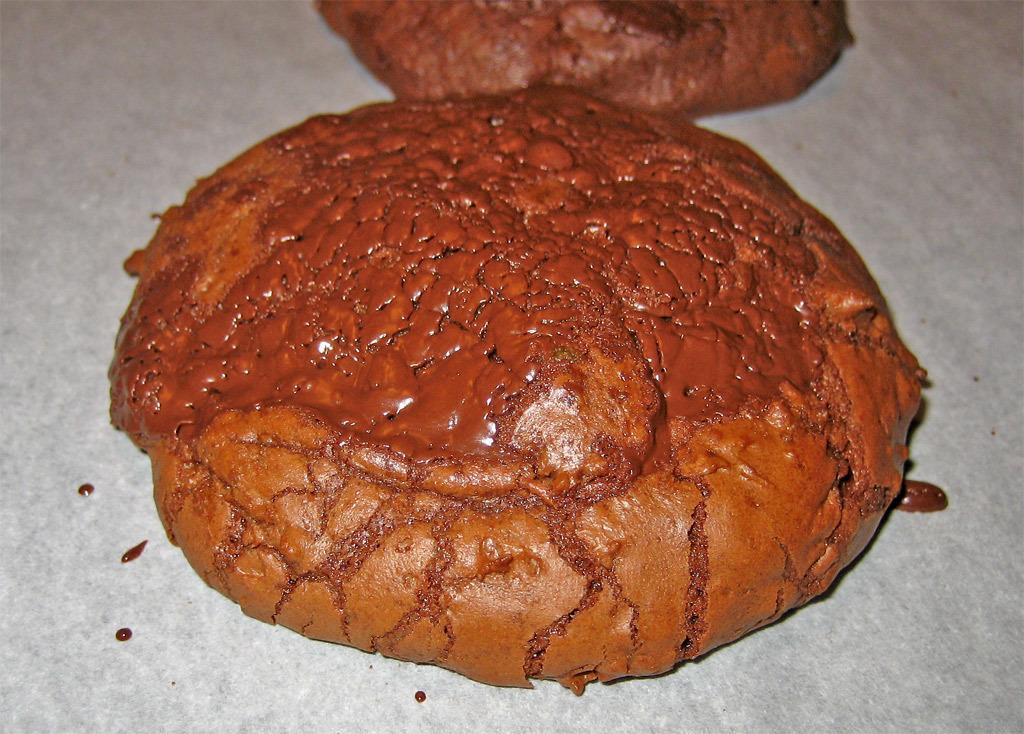Could you give a brief overview of what you see in this image? In this image I can see 2 cookies. 